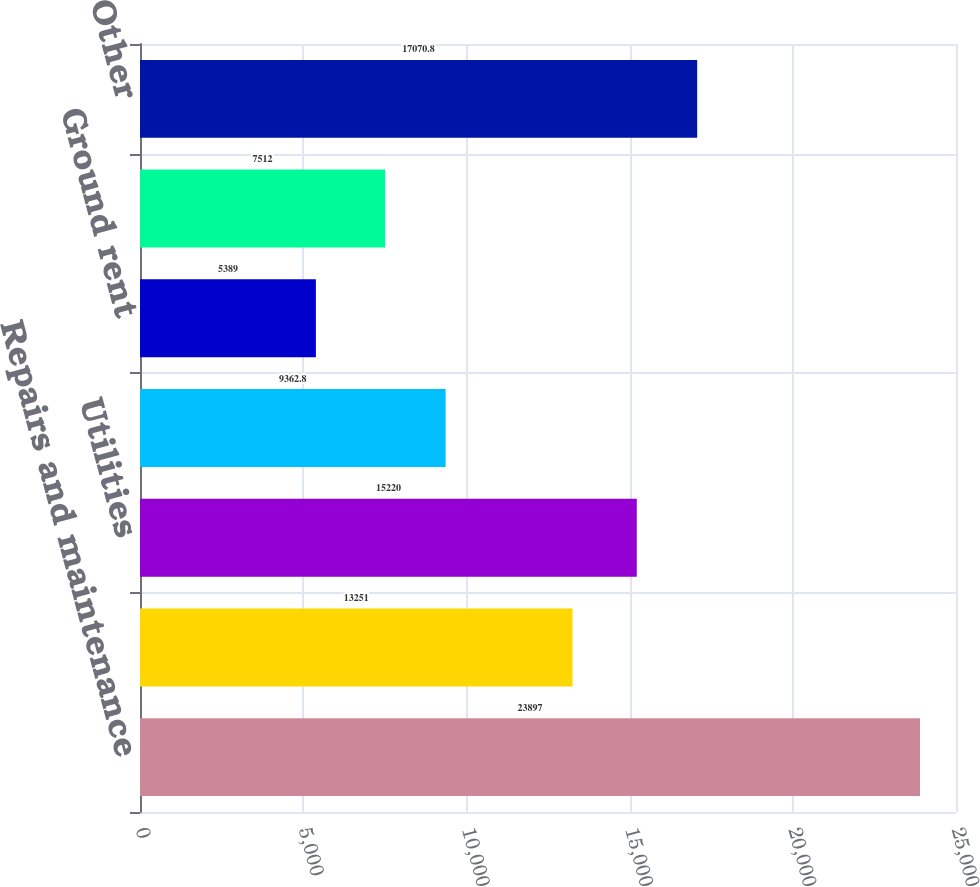Convert chart. <chart><loc_0><loc_0><loc_500><loc_500><bar_chart><fcel>Repairs and maintenance<fcel>Management fees and costs<fcel>Utilities<fcel>Payroll-properties<fcel>Ground rent<fcel>Insurance<fcel>Other<nl><fcel>23897<fcel>13251<fcel>15220<fcel>9362.8<fcel>5389<fcel>7512<fcel>17070.8<nl></chart> 